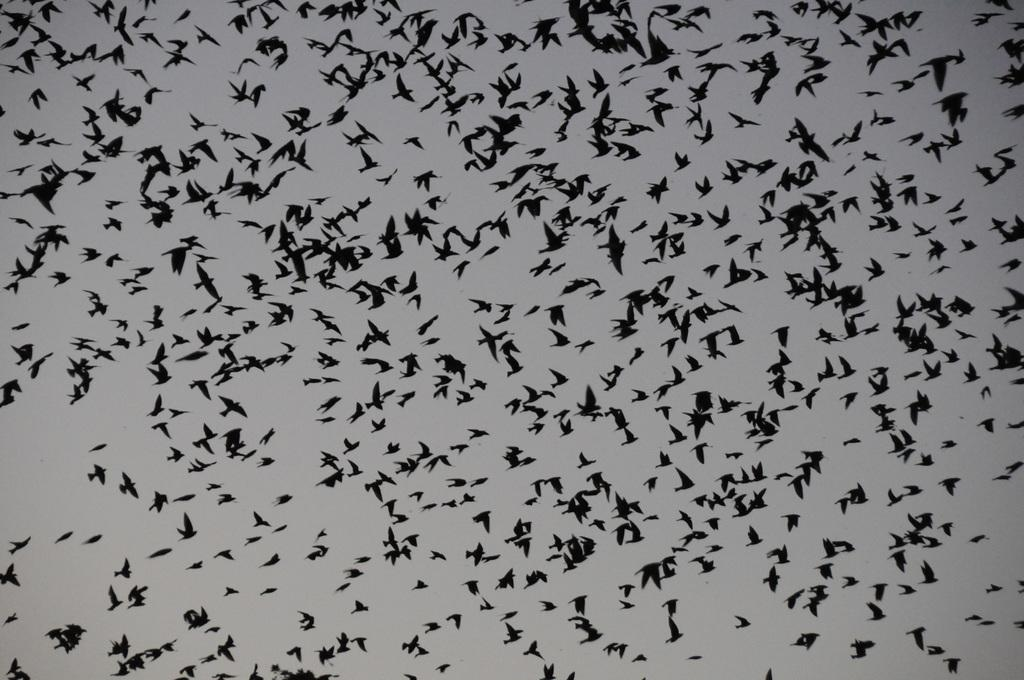What type of animals can be seen in the image? There are birds in the image. What color are the birds? The birds are black in color. Where are the birds located in the image? The birds are in the sky. What type of frame is holding the substance in the image? There is no frame or substance present in the image; it features black birds in the sky. 